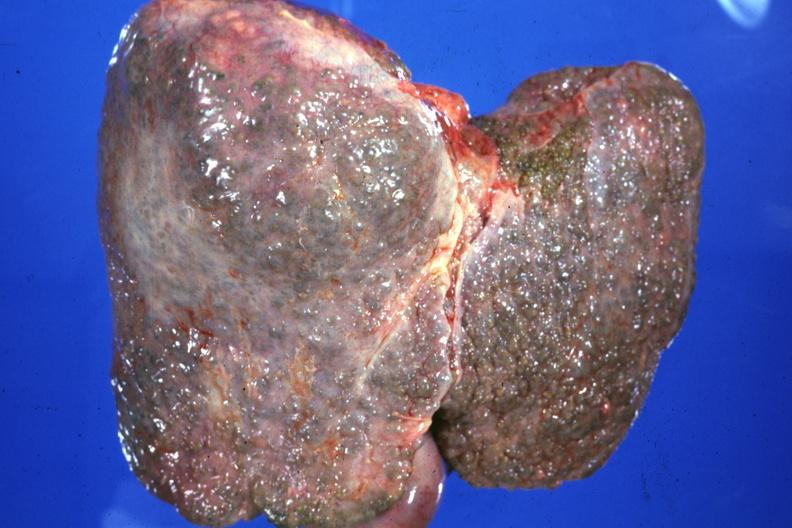what does this image show?
Answer the question using a single word or phrase. External view typical alcoholic type cirrhosis 